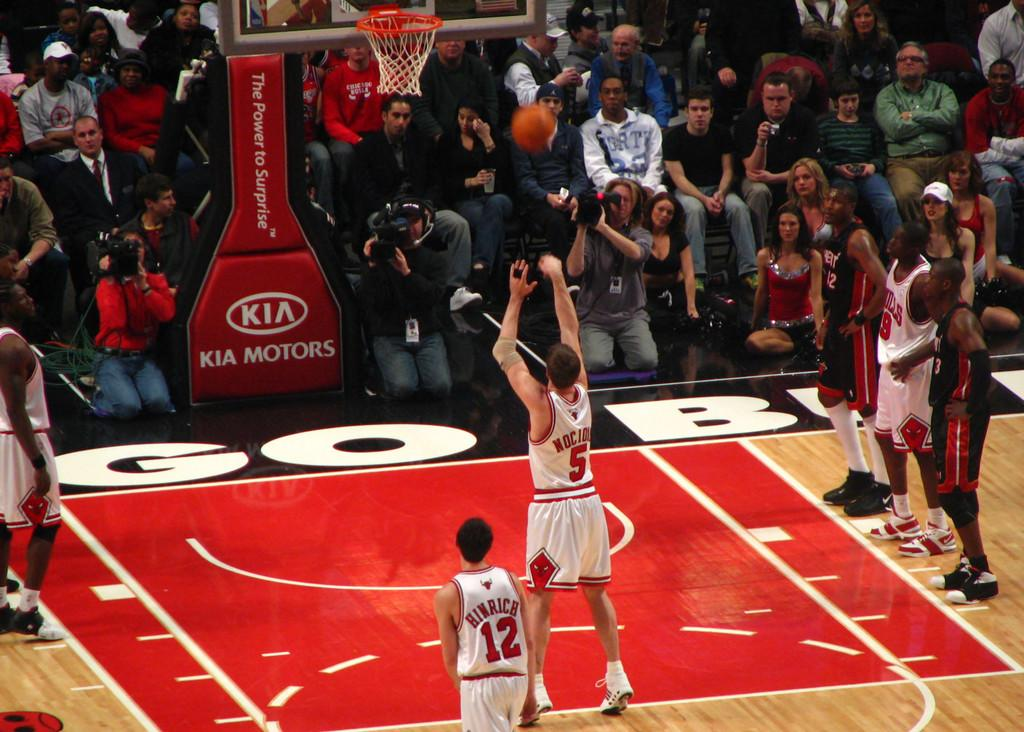Provide a one-sentence caption for the provided image. A Chicago Bulls player doing a layup in front of a bunch of other people. 